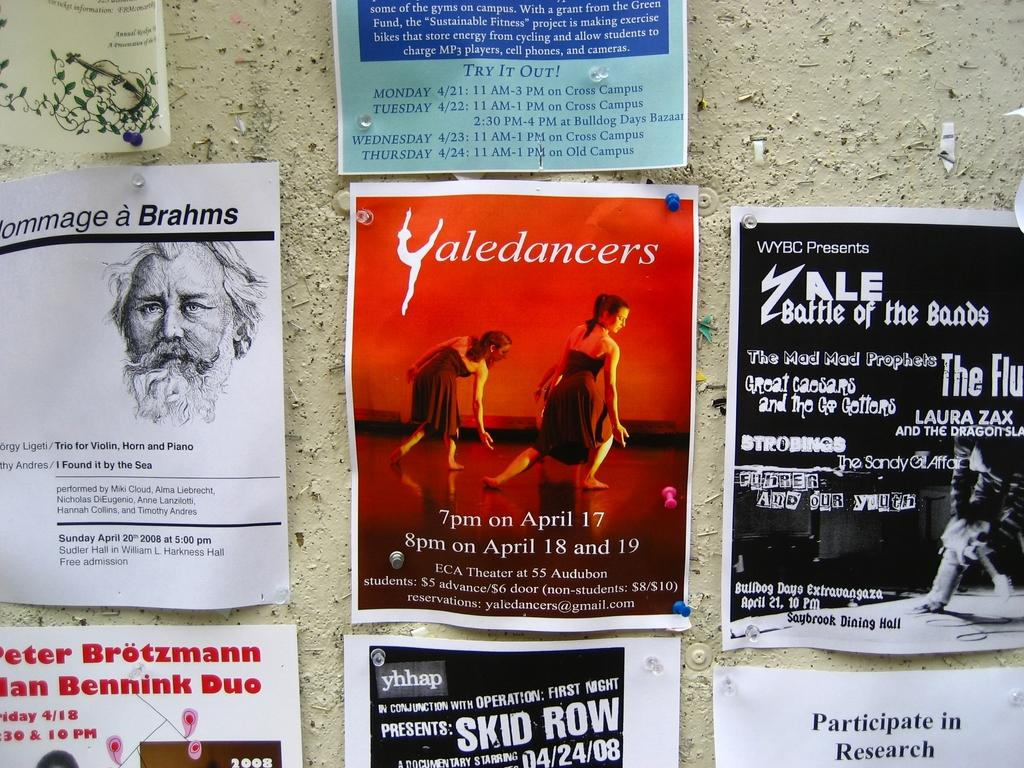Provide a one-sentence caption for the provided image. A wall filled with flyers from different places with a center poster reading Yaledancers. 